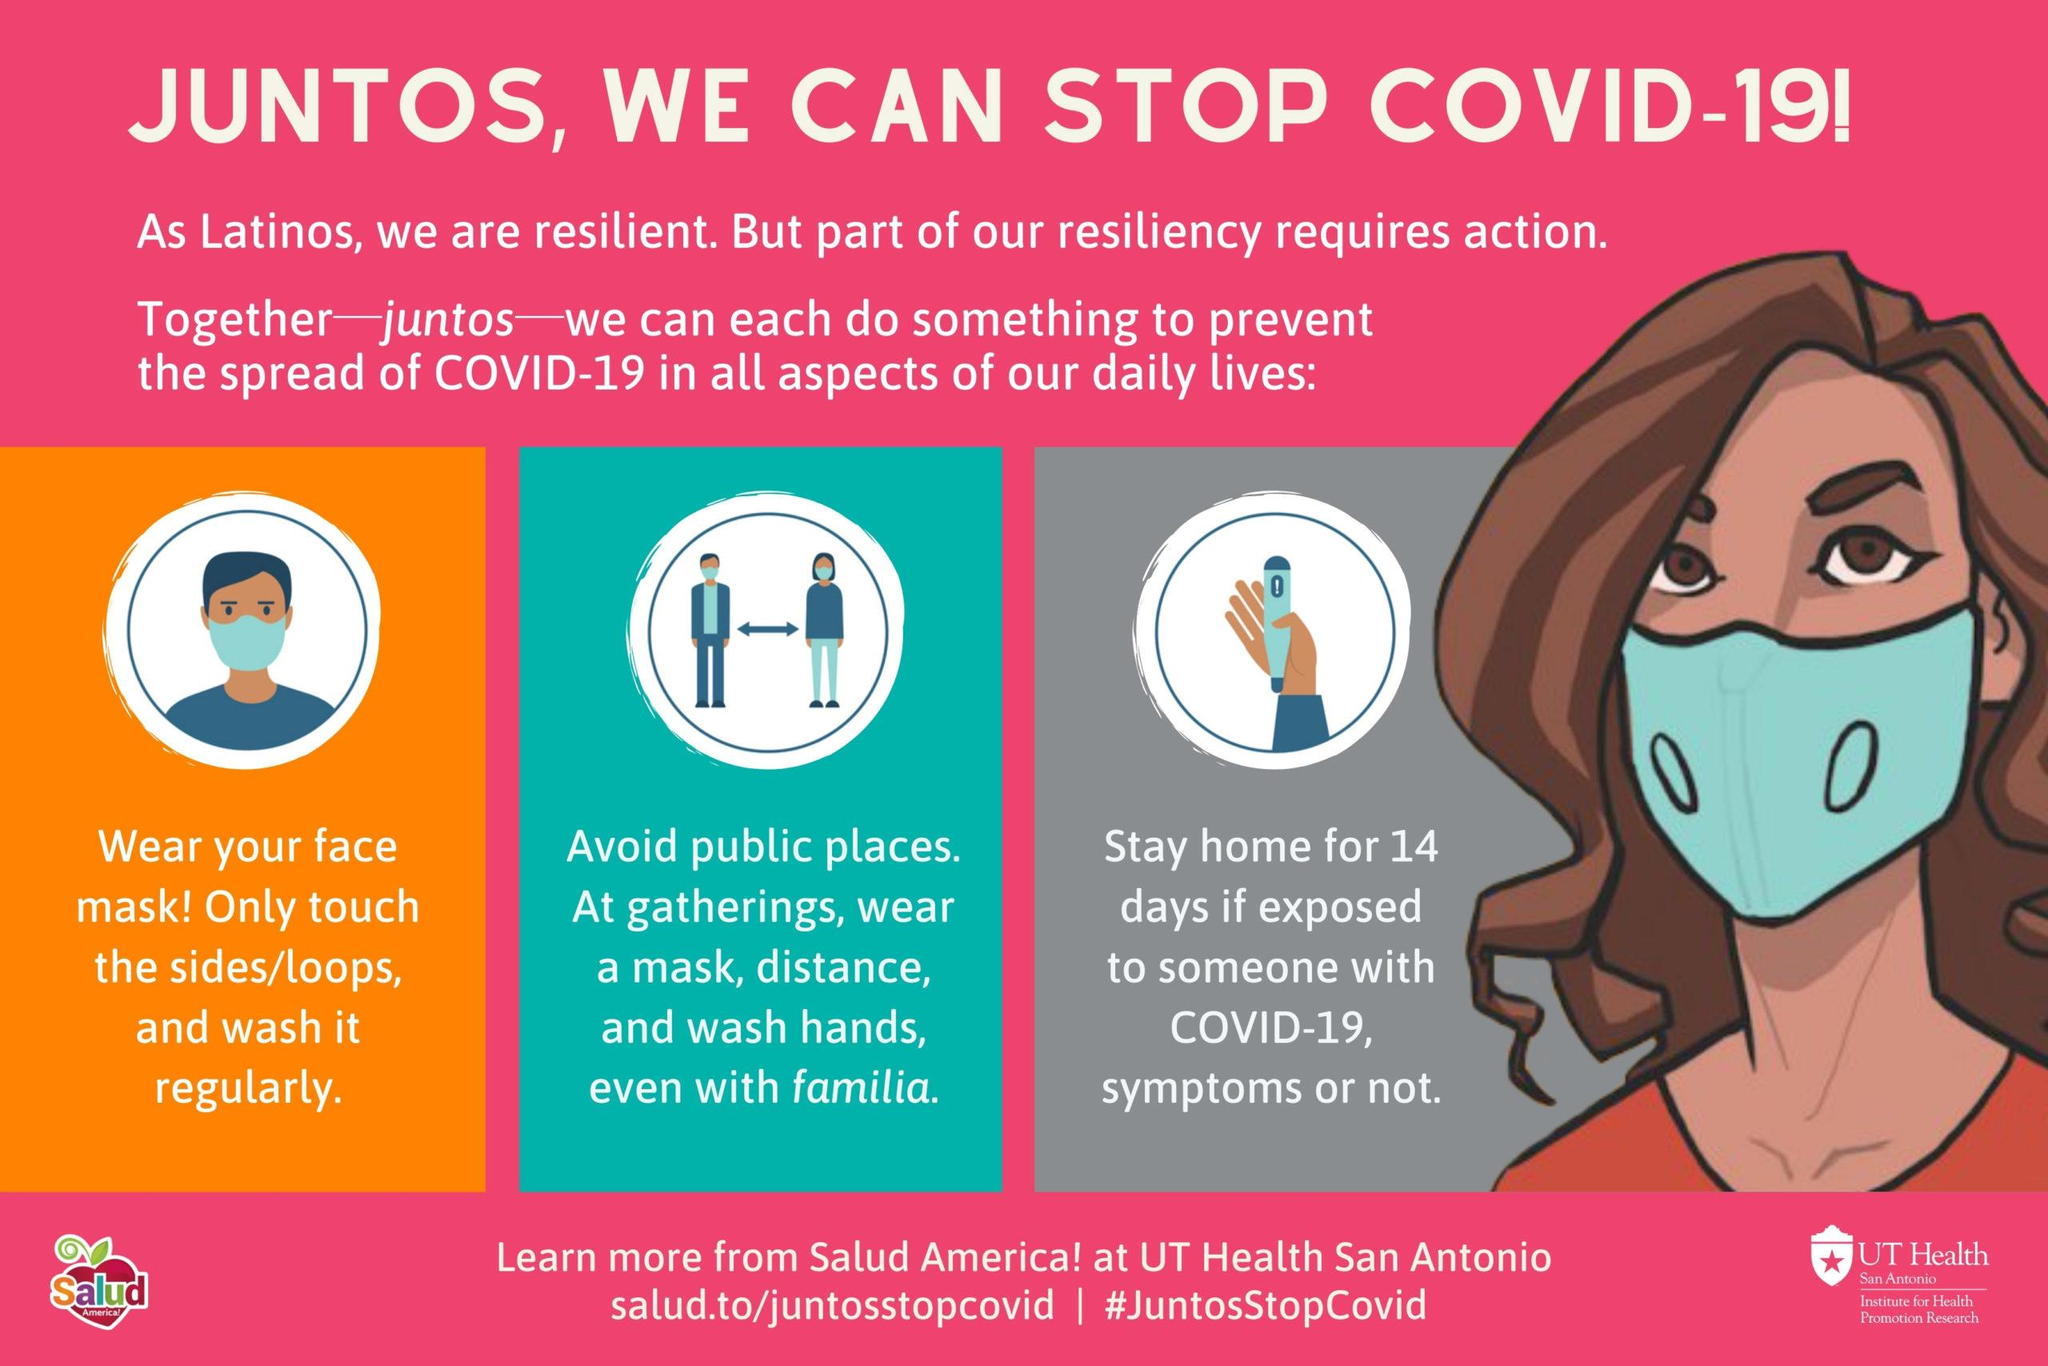Specify some key components in this picture. It is important to only touch the sides or loops of a face mask, as touching other parts of the mask could compromise its effectiveness or cause irritation to the skin. If one is exposed to someone with COVID-19, it is recommended that they stay home from work or public places for 14 days as a precautionary measure to prevent the spread of the virus. Resilient individuals, particularly Latinos, are those who are able to adapt and bounce back from adversity. The face mask worn by the lady is blue. It is recommended to wash the face mask regularly for optimal results. 